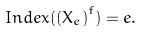Convert formula to latex. <formula><loc_0><loc_0><loc_500><loc_500>I n d e x ( \left ( X _ { e } \right ) ^ { f } ) = e .</formula> 